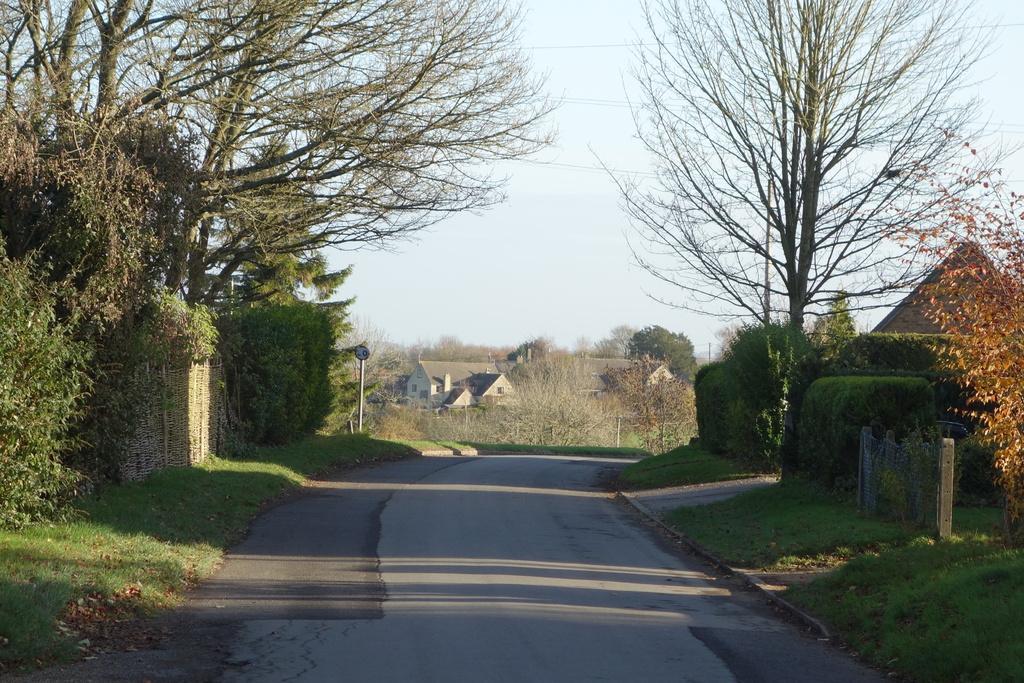Could you give a brief overview of what you see in this image? In front of the image there is a road, besides the road there is grass on the surface and there are sign boards, bushes, wooden fence, trees and buildings, at the top of the image there are clouds in the sky and there are electrical cables. 